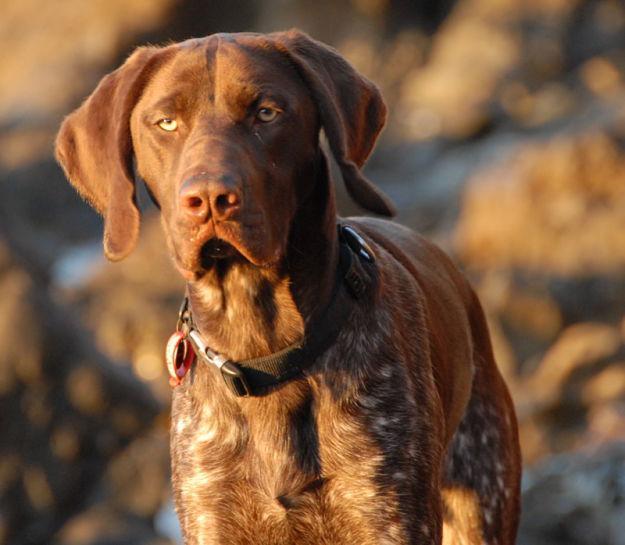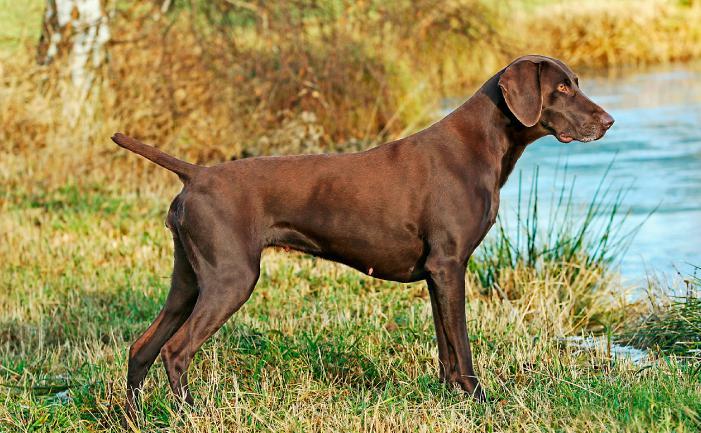The first image is the image on the left, the second image is the image on the right. Considering the images on both sides, is "Each image contains a single dog, and each dog pictured is facing forward with its head upright and both eyes visible." valid? Answer yes or no. No. The first image is the image on the left, the second image is the image on the right. Analyze the images presented: Is the assertion "There are two dogs looking forward at the camera" valid? Answer yes or no. No. 